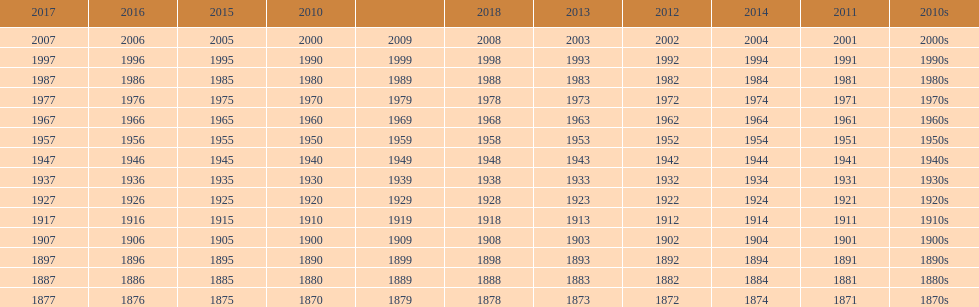Which decade is the only one to have fewer years in its row than the others? 2010s. 